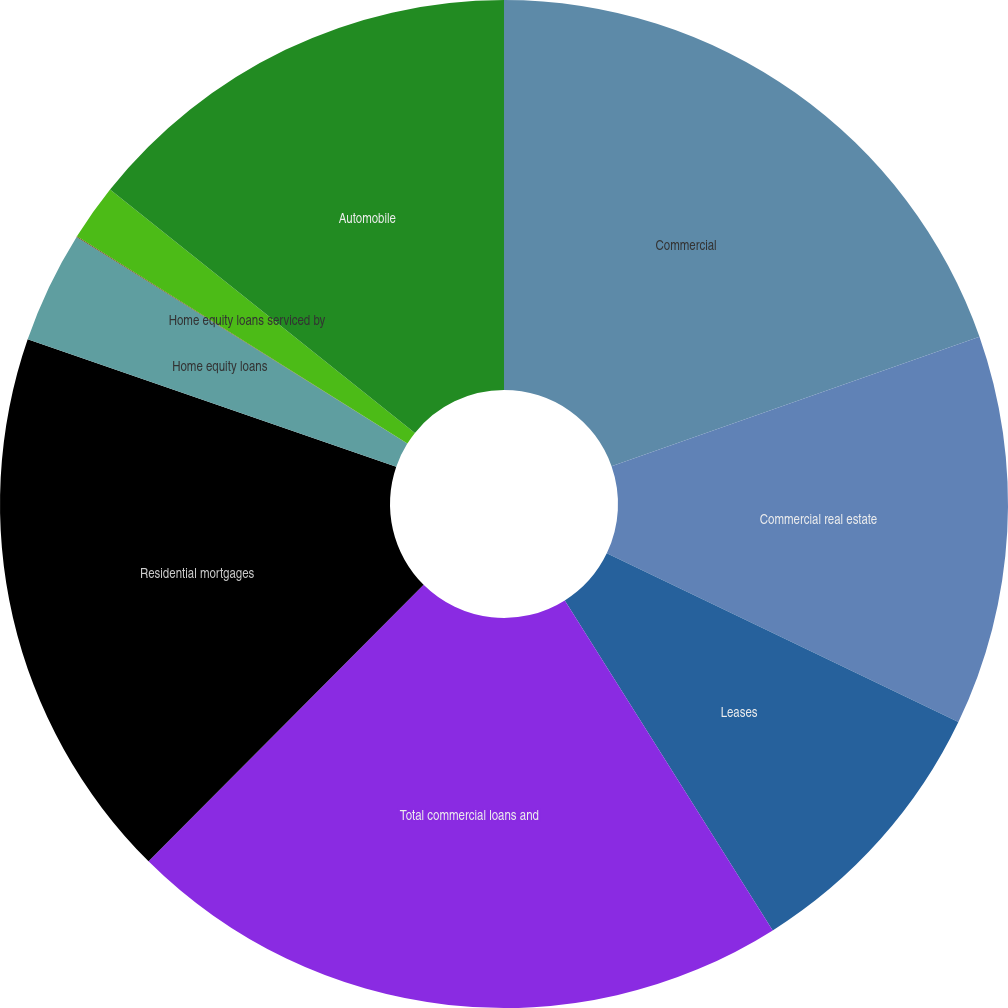<chart> <loc_0><loc_0><loc_500><loc_500><pie_chart><fcel>Commercial<fcel>Commercial real estate<fcel>Leases<fcel>Total commercial loans and<fcel>Residential mortgages<fcel>Home equity loans<fcel>Home equity lines of credit<fcel>Home equity loans serviced by<fcel>Automobile<nl><fcel>19.62%<fcel>12.5%<fcel>8.93%<fcel>21.41%<fcel>17.84%<fcel>3.59%<fcel>0.02%<fcel>1.81%<fcel>14.28%<nl></chart> 